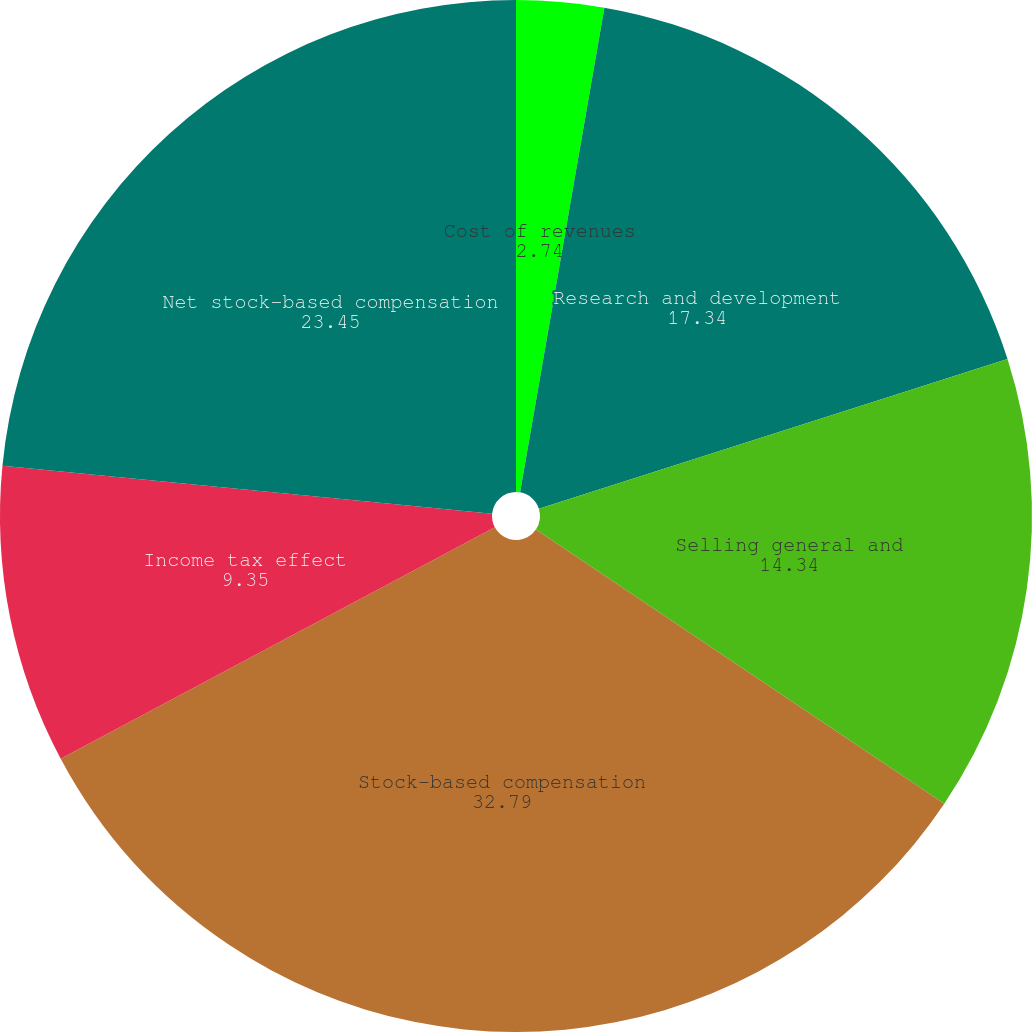Convert chart to OTSL. <chart><loc_0><loc_0><loc_500><loc_500><pie_chart><fcel>Cost of revenues<fcel>Research and development<fcel>Selling general and<fcel>Stock-based compensation<fcel>Income tax effect<fcel>Net stock-based compensation<nl><fcel>2.74%<fcel>17.34%<fcel>14.34%<fcel>32.79%<fcel>9.35%<fcel>23.45%<nl></chart> 